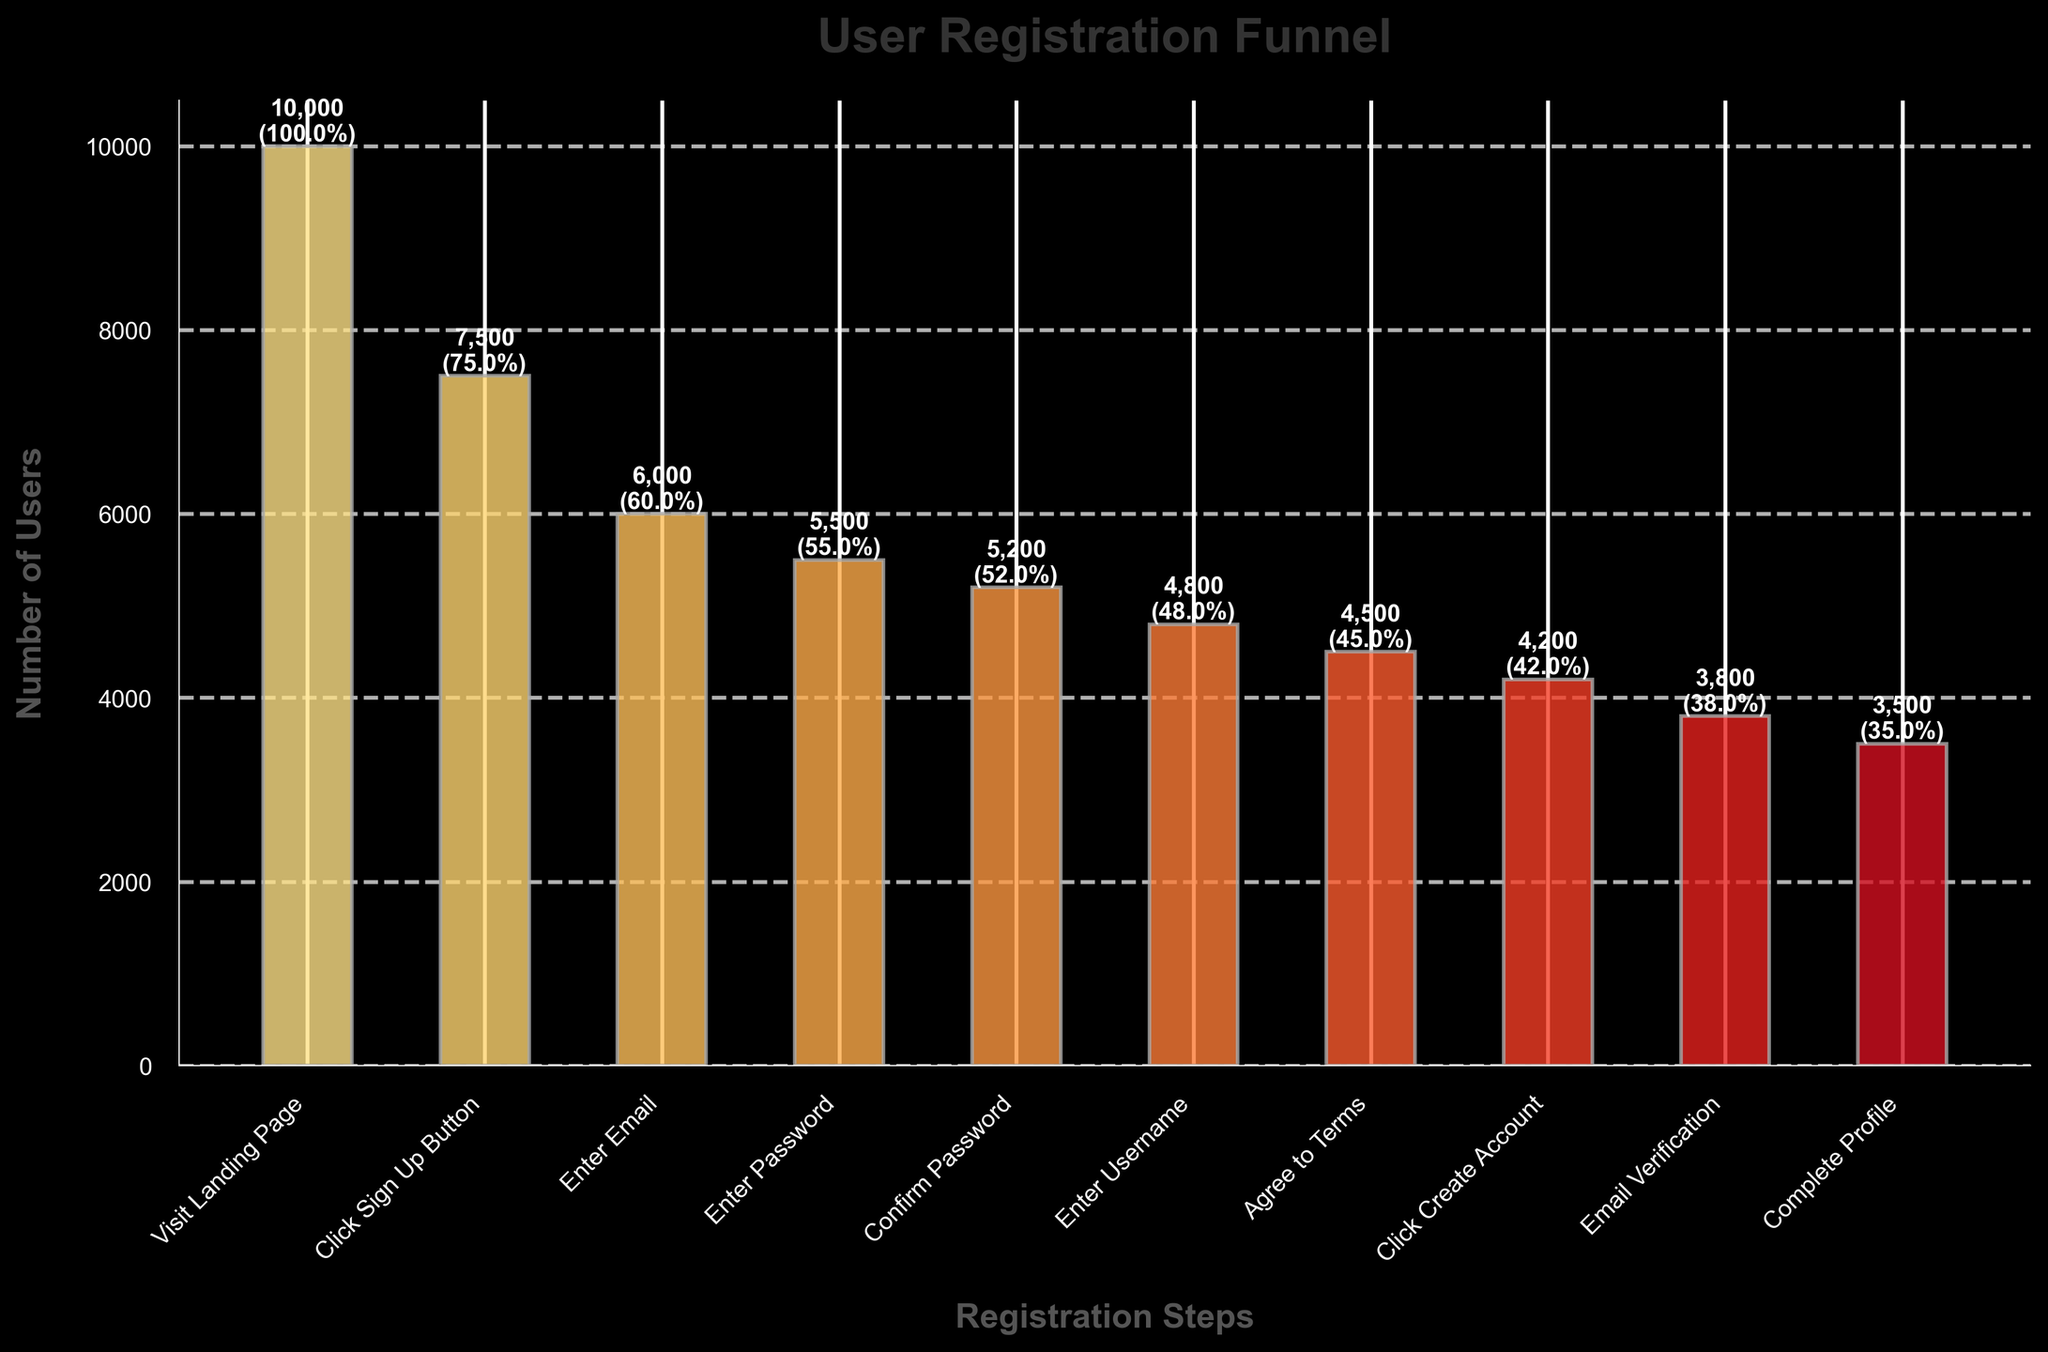What is the title of the funnel chart? The title can be found at the top of the chart. It is labeled as "User Registration Funnel".
Answer: User Registration Funnel How many total steps are involved in the user registration process? The number of steps corresponds to the number of bars in the funnel chart. Counting each label on the x-axis, there are 10 steps.
Answer: 10 Which step has the highest number of users? The step with the highest number of users will be the tallest bar on the chart, which is "Visit Landing Page" with 10,000 users.
Answer: Visit Landing Page What is the conversion rate from clicking the "Sign Up Button" to entering the email? The conversion rate from "Click Sign Up Button" to "Enter Email" is calculated by taking the number of users entering their email (6000) and dividing it by the number of users who clicked the "Sign Up Button" (7500), resulting in 6000/7500 = 0.8, or 80%.
Answer: 80% How many users complete the "Enter Username" step? Referring to the chart, the number of users who enter the username is shown on the respective bar, which is 4800 users.
Answer: 4800 Which two consecutive steps show the largest drop in conversion rate? By examining the conversion rates between consecutive steps, the largest drop occurs from "Email Verification" (38%) to "Complete Profile" (35%), a difference of 3%.
Answer: Email Verification to Complete Profile What percentage of users who visit the landing page end up verifying their email? Starting with 10,000 users at the landing page and ending with 3800 users who verify their email, the percentage is 3800/10000 = 0.38, or 38%.
Answer: 38% How many users drop off between the "Enter Email" and "Enter Password" steps? The difference in the number of users between the "Enter Email" step (6000) and the "Enter Password" step (5500) is 6000 - 5500 = 500 users.
Answer: 500 Which step has the smallest number of users? The smallest number of users corresponds to the shortest bar on the chart, which is the "Complete Profile" step with 3500 users.
Answer: Complete Profile Which step has a conversion rate closest to 50%? By closely examining the conversion rates on the data labels, the "Confirm Password" step has a conversion rate of 52%, which is closest to 50%.
Answer: Confirm Password 